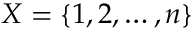<formula> <loc_0><loc_0><loc_500><loc_500>X = \{ 1 , 2 , \dots , n \}</formula> 